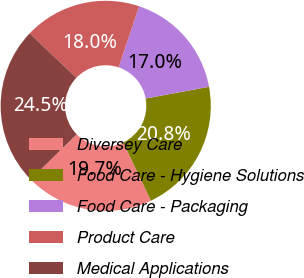Convert chart. <chart><loc_0><loc_0><loc_500><loc_500><pie_chart><fcel>Diversey Care<fcel>Food Care - Hygiene Solutions<fcel>Food Care - Packaging<fcel>Product Care<fcel>Medical Applications<nl><fcel>19.74%<fcel>20.82%<fcel>16.95%<fcel>18.03%<fcel>24.46%<nl></chart> 